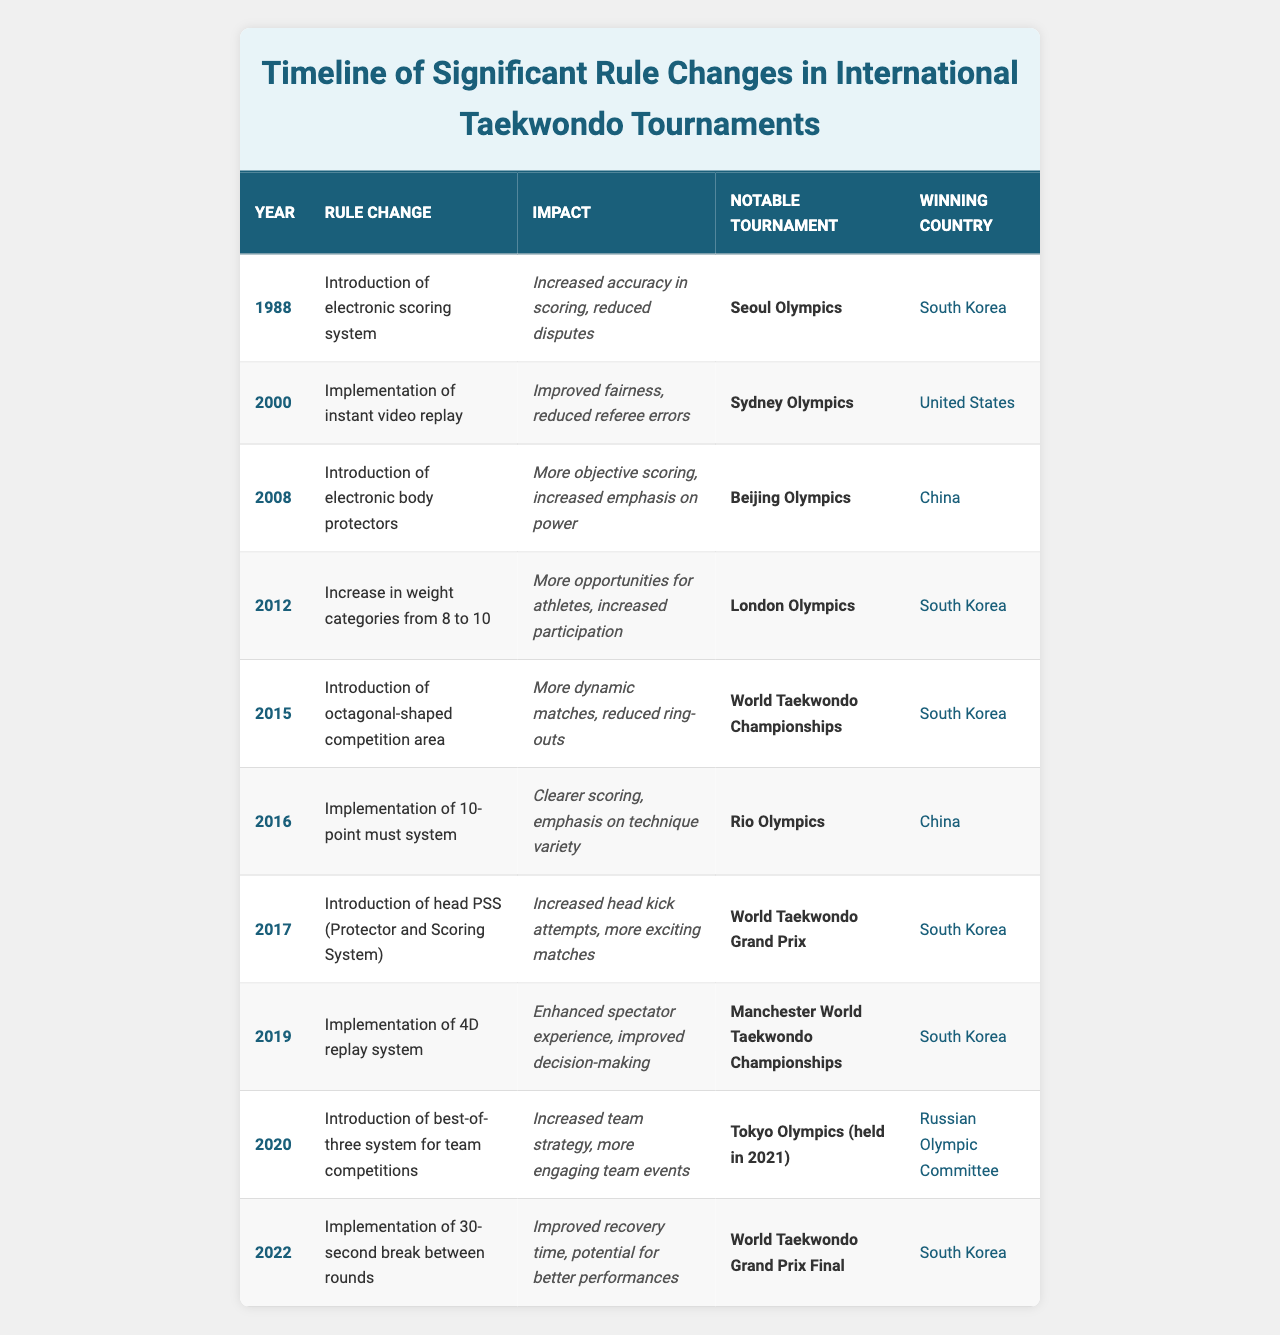What year was the introduction of the electronic scoring system? From the table, the electronic scoring system was introduced in the year 1988.
Answer: 1988 Which country won the Seoul Olympics in 1988? According to the table, South Korea won the Seoul Olympics in 1988.
Answer: South Korea What was the impact of the introduction of electronic body protectors in 2008? The table states that the introduction of electronic body protectors led to more objective scoring and an increased emphasis on power.
Answer: More objective scoring, increased emphasis on power How many notable tournaments were mentioned before 2010? The table lists notable tournaments from 1988 to 2019, identifying 6 tournaments (Seoul Olympics, Sydney Olympics, Beijing Olympics, London Olympics, 2015 World Taekwondo Championships, and Rio Olympics) before 2010.
Answer: 6 Which rule change occurred in 2016 and what was its impact? The rule change in 2016 was the implementation of the 10-point must system, which resulted in clearer scoring and an emphasis on technique variety.
Answer: Implementation of 10-point must system, clearer scoring Did the introduction of the 4D replay system occur before or after the introduction of electronic body protectors? By examining the table, the 4D replay system was implemented in 2019, which is after the introduction of electronic body protectors in 2008.
Answer: After What are the winning countries for the notable tournaments held in 2012 and 2016? According to the table, South Korea won the London Olympics in 2012, and China won the Rio Olympics in 2016.
Answer: South Korea (2012), China (2016) How many rule changes were introduced between 2000 and 2015? The table shows a total of 5 rule changes introduced from 2000 (instant video replay) to 2015 (octagonal-shaped competition area).
Answer: 5 What was the significant rule change in 2020 and how did it affect team competitions? The significant rule change in 2020 was introducing a best-of-three system for team competitions, which increased strategy and engagement in team events.
Answer: Best-of-three system increased strategy Which country had the most notable tournament victories from the data provided? Analyzing the table shows that South Korea has four tournament wins (1988, 2012, 2015, and 2019), more than any other country.
Answer: South Korea 